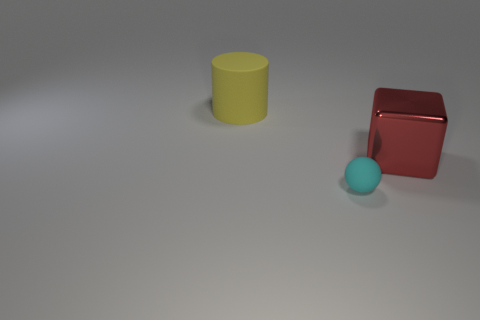What number of objects are to the left of the red cube and behind the cyan rubber ball?
Provide a succinct answer. 1. How many large green cylinders are made of the same material as the tiny cyan sphere?
Ensure brevity in your answer.  0. There is a tiny sphere that is the same material as the large yellow cylinder; what is its color?
Ensure brevity in your answer.  Cyan. Is the number of big objects less than the number of big shiny blocks?
Offer a very short reply. No. There is a large thing that is behind the large thing right of the matte object that is on the left side of the small thing; what is it made of?
Provide a short and direct response. Rubber. What is the material of the large red thing?
Keep it short and to the point. Metal. There is a matte object to the left of the tiny cyan rubber thing; is its color the same as the thing that is in front of the large red block?
Your response must be concise. No. Is the number of tiny matte cylinders greater than the number of red objects?
Keep it short and to the point. No. What number of shiny objects have the same color as the tiny matte sphere?
Provide a short and direct response. 0. What is the material of the thing that is both in front of the big cylinder and to the left of the red metallic cube?
Your answer should be very brief. Rubber. 